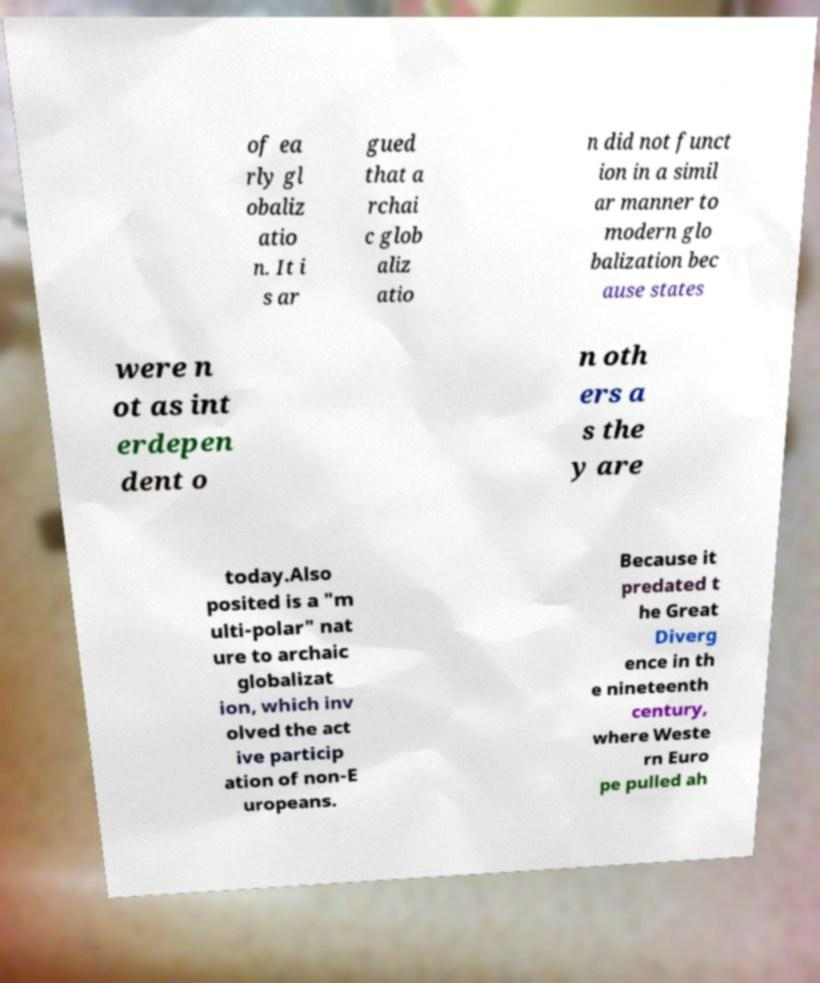For documentation purposes, I need the text within this image transcribed. Could you provide that? of ea rly gl obaliz atio n. It i s ar gued that a rchai c glob aliz atio n did not funct ion in a simil ar manner to modern glo balization bec ause states were n ot as int erdepen dent o n oth ers a s the y are today.Also posited is a "m ulti-polar" nat ure to archaic globalizat ion, which inv olved the act ive particip ation of non-E uropeans. Because it predated t he Great Diverg ence in th e nineteenth century, where Weste rn Euro pe pulled ah 